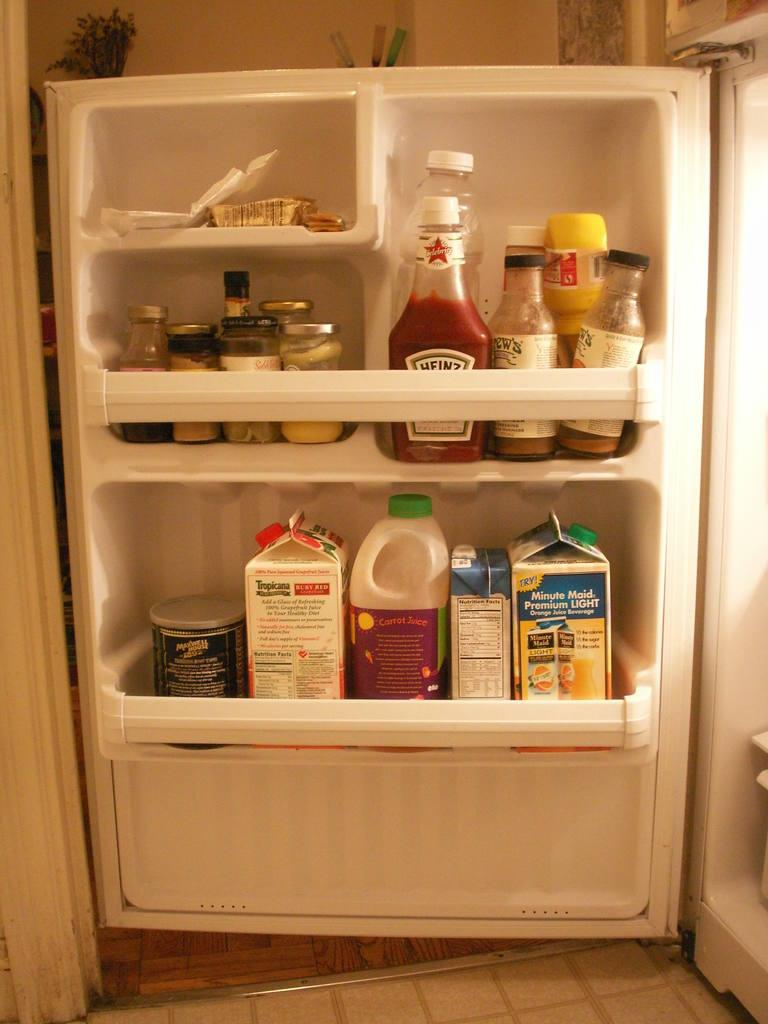<image>
Provide a brief description of the given image. An open fridge has condiments such as ketchup and juices such as carrot juice on its shelves. 